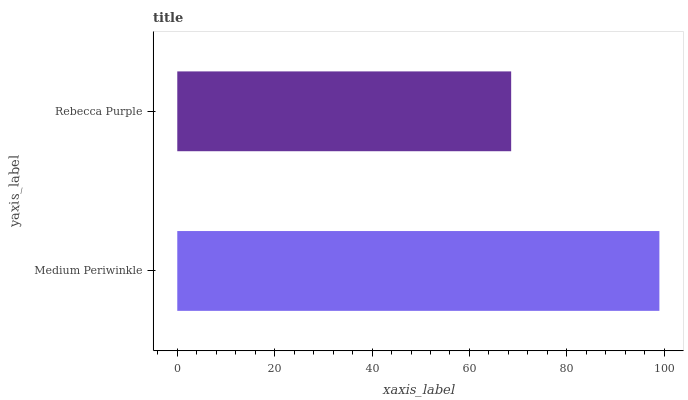Is Rebecca Purple the minimum?
Answer yes or no. Yes. Is Medium Periwinkle the maximum?
Answer yes or no. Yes. Is Rebecca Purple the maximum?
Answer yes or no. No. Is Medium Periwinkle greater than Rebecca Purple?
Answer yes or no. Yes. Is Rebecca Purple less than Medium Periwinkle?
Answer yes or no. Yes. Is Rebecca Purple greater than Medium Periwinkle?
Answer yes or no. No. Is Medium Periwinkle less than Rebecca Purple?
Answer yes or no. No. Is Medium Periwinkle the high median?
Answer yes or no. Yes. Is Rebecca Purple the low median?
Answer yes or no. Yes. Is Rebecca Purple the high median?
Answer yes or no. No. Is Medium Periwinkle the low median?
Answer yes or no. No. 